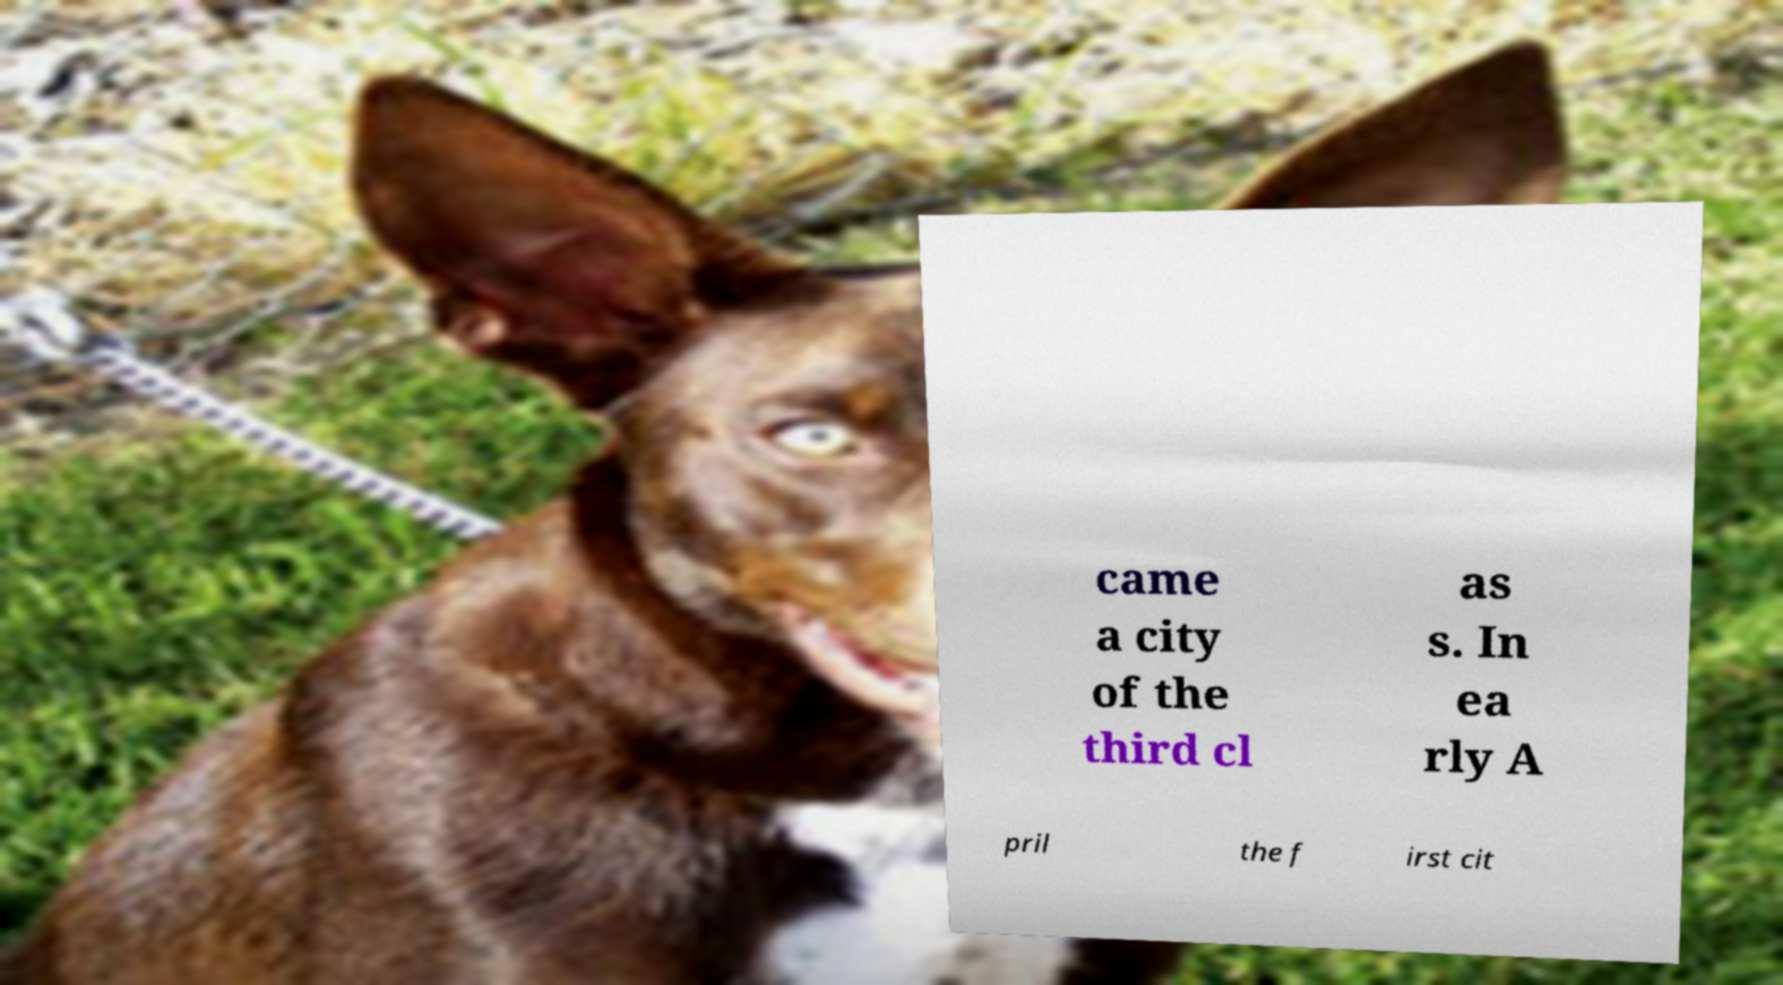Please read and relay the text visible in this image. What does it say? came a city of the third cl as s. In ea rly A pril the f irst cit 